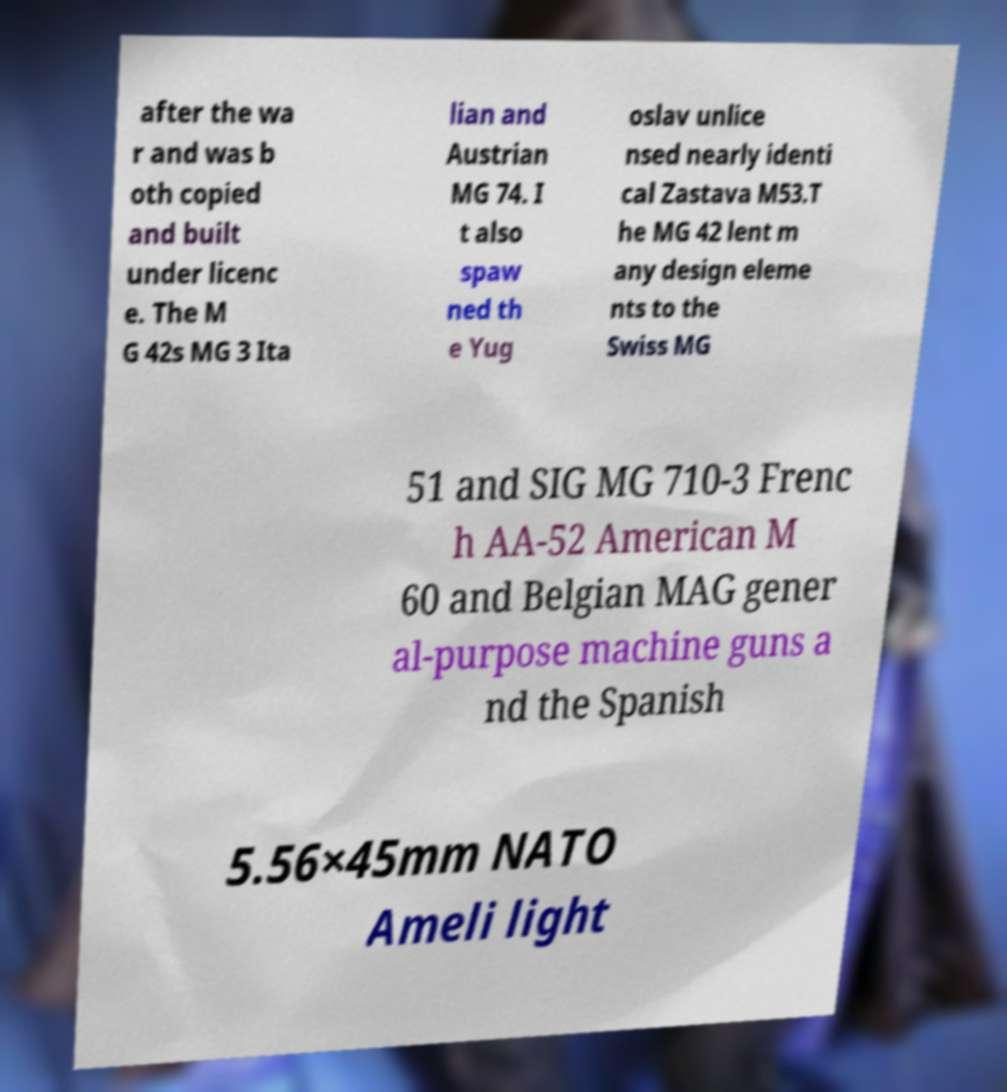What messages or text are displayed in this image? I need them in a readable, typed format. after the wa r and was b oth copied and built under licenc e. The M G 42s MG 3 Ita lian and Austrian MG 74. I t also spaw ned th e Yug oslav unlice nsed nearly identi cal Zastava M53.T he MG 42 lent m any design eleme nts to the Swiss MG 51 and SIG MG 710-3 Frenc h AA-52 American M 60 and Belgian MAG gener al-purpose machine guns a nd the Spanish 5.56×45mm NATO Ameli light 